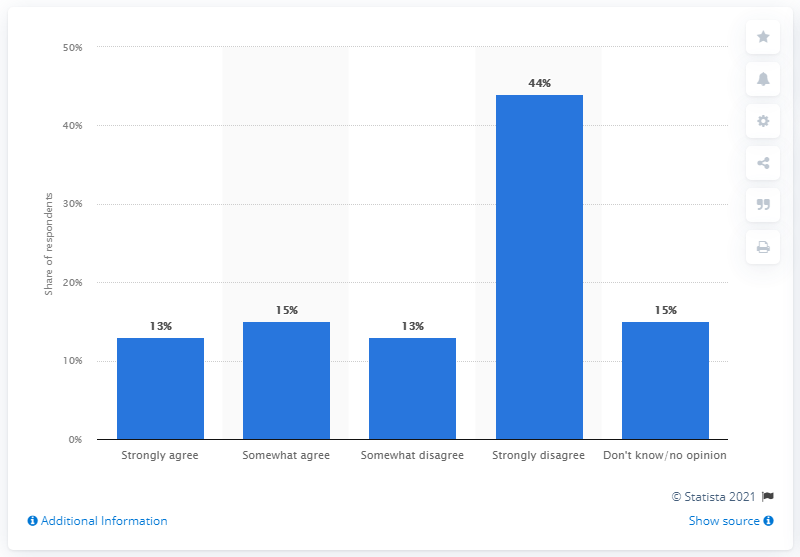Draw attention to some important aspects in this diagram. According to the survey, 13% of respondents strongly agreed with the suspension of live sports. 